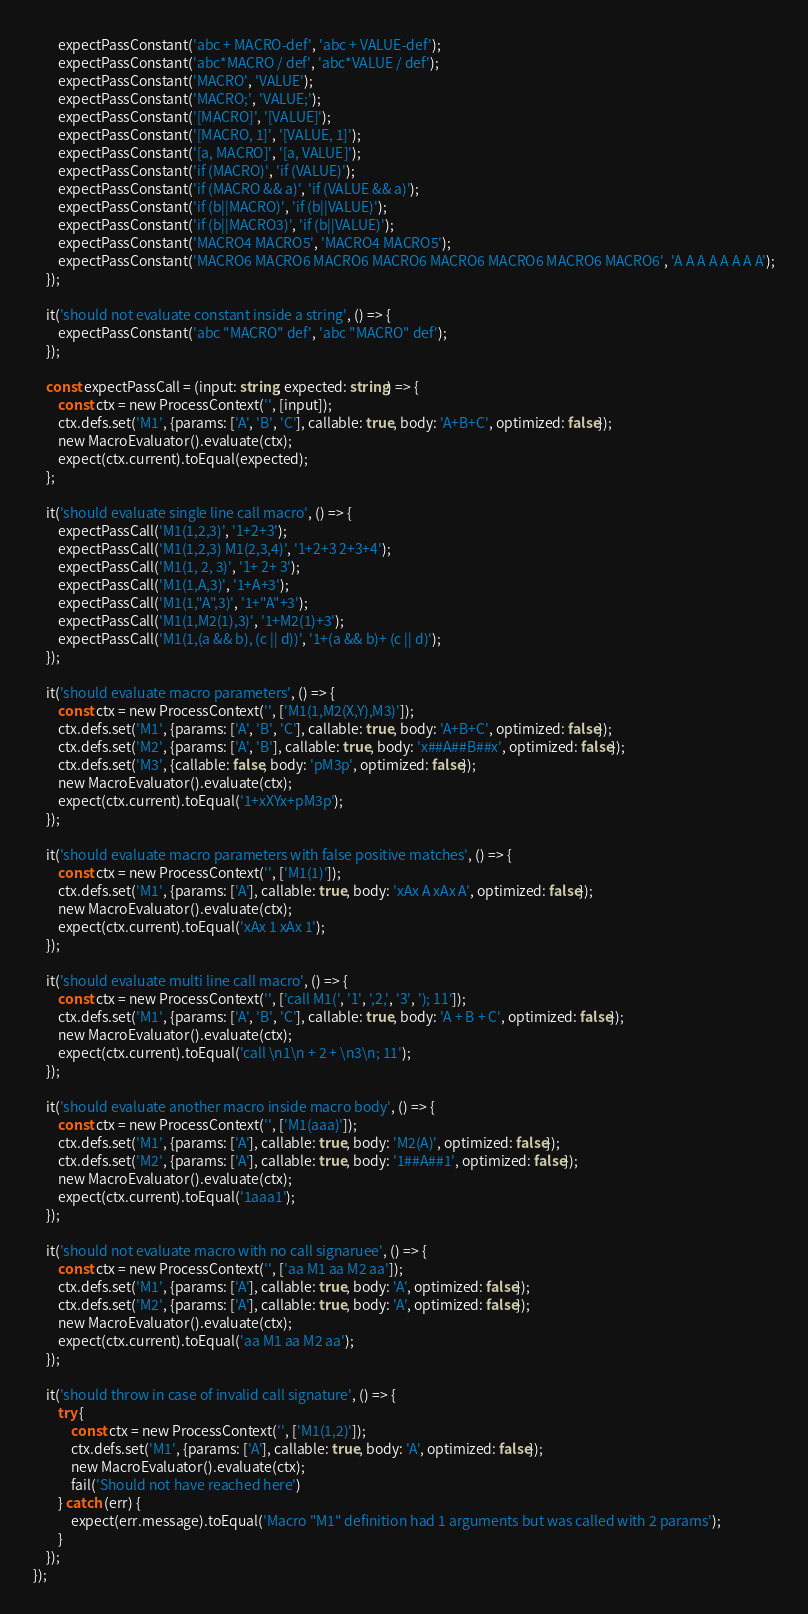Convert code to text. <code><loc_0><loc_0><loc_500><loc_500><_TypeScript_>        expectPassConstant('abc + MACRO-def', 'abc + VALUE-def');
        expectPassConstant('abc*MACRO / def', 'abc*VALUE / def');
        expectPassConstant('MACRO', 'VALUE');
        expectPassConstant('MACRO;', 'VALUE;');
        expectPassConstant('[MACRO]', '[VALUE]');
        expectPassConstant('[MACRO, 1]', '[VALUE, 1]');
        expectPassConstant('[a, MACRO]', '[a, VALUE]');
        expectPassConstant('if (MACRO)', 'if (VALUE)');
        expectPassConstant('if (MACRO && a)', 'if (VALUE && a)');
        expectPassConstant('if (b||MACRO)', 'if (b||VALUE)');
        expectPassConstant('if (b||MACRO3)', 'if (b||VALUE)');
        expectPassConstant('MACRO4 MACRO5', 'MACRO4 MACRO5');
        expectPassConstant('MACRO6 MACRO6 MACRO6 MACRO6 MACRO6 MACRO6 MACRO6 MACRO6', 'A A A A A A A A');
    });

    it('should not evaluate constant inside a string', () => {
        expectPassConstant('abc "MACRO" def', 'abc "MACRO" def');
    });

    const expectPassCall = (input: string, expected: string) => {
        const ctx = new ProcessContext('', [input]);
        ctx.defs.set('M1', {params: ['A', 'B', 'C'], callable: true, body: 'A+B+C', optimized: false});
        new MacroEvaluator().evaluate(ctx);
        expect(ctx.current).toEqual(expected);
    };

    it('should evaluate single line call macro', () => {
        expectPassCall('M1(1,2,3)', '1+2+3');
        expectPassCall('M1(1,2,3) M1(2,3,4)', '1+2+3 2+3+4');
        expectPassCall('M1(1, 2, 3)', '1+ 2+ 3');
        expectPassCall('M1(1,A,3)', '1+A+3');
        expectPassCall('M1(1,"A",3)', '1+"A"+3');
        expectPassCall('M1(1,M2(1),3)', '1+M2(1)+3');
        expectPassCall('M1(1,(a && b), (c || d))', '1+(a && b)+ (c || d)');
    });

    it('should evaluate macro parameters', () => {
        const ctx = new ProcessContext('', ['M1(1,M2(X,Y),M3)']);
        ctx.defs.set('M1', {params: ['A', 'B', 'C'], callable: true, body: 'A+B+C', optimized: false});
        ctx.defs.set('M2', {params: ['A', 'B'], callable: true, body: 'x##A##B##x', optimized: false});
        ctx.defs.set('M3', {callable: false, body: 'pM3p', optimized: false});
        new MacroEvaluator().evaluate(ctx);
        expect(ctx.current).toEqual('1+xXYx+pM3p');
    });

    it('should evaluate macro parameters with false positive matches', () => {
        const ctx = new ProcessContext('', ['M1(1)']);
        ctx.defs.set('M1', {params: ['A'], callable: true, body: 'xAx A xAx A', optimized: false});
        new MacroEvaluator().evaluate(ctx);
        expect(ctx.current).toEqual('xAx 1 xAx 1');
    });

    it('should evaluate multi line call macro', () => {
        const ctx = new ProcessContext('', ['call M1(', '1', ',2,', '3', '); 11']);
        ctx.defs.set('M1', {params: ['A', 'B', 'C'], callable: true, body: 'A + B + C', optimized: false});
        new MacroEvaluator().evaluate(ctx);
        expect(ctx.current).toEqual('call \n1\n + 2 + \n3\n; 11');
    });

    it('should evaluate another macro inside macro body', () => {
        const ctx = new ProcessContext('', ['M1(aaa)']);
        ctx.defs.set('M1', {params: ['A'], callable: true, body: 'M2(A)', optimized: false});
        ctx.defs.set('M2', {params: ['A'], callable: true, body: '1##A##1', optimized: false});
        new MacroEvaluator().evaluate(ctx);
        expect(ctx.current).toEqual('1aaa1');
    });

    it('should not evaluate macro with no call signaruee', () => {
        const ctx = new ProcessContext('', ['aa M1 aa M2 aa']);
        ctx.defs.set('M1', {params: ['A'], callable: true, body: 'A', optimized: false});
        ctx.defs.set('M2', {params: ['A'], callable: true, body: 'A', optimized: false});
        new MacroEvaluator().evaluate(ctx);
        expect(ctx.current).toEqual('aa M1 aa M2 aa');
    });

    it('should throw in case of invalid call signature', () => {
        try {
            const ctx = new ProcessContext('', ['M1(1,2)']);
            ctx.defs.set('M1', {params: ['A'], callable: true, body: 'A', optimized: false});
            new MacroEvaluator().evaluate(ctx);
            fail('Should not have reached here')
        } catch (err) {
            expect(err.message).toEqual('Macro "M1" definition had 1 arguments but was called with 2 params');
        }
    });
});
</code> 